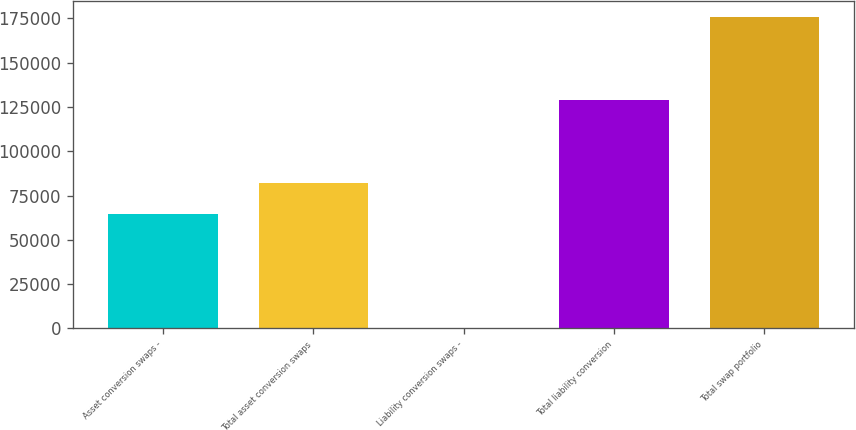Convert chart. <chart><loc_0><loc_0><loc_500><loc_500><bar_chart><fcel>Asset conversion swaps -<fcel>Total asset conversion swaps<fcel>Liability conversion swaps -<fcel>Total liability conversion<fcel>Total swap portfolio<nl><fcel>64408<fcel>81969.3<fcel>319<fcel>128766<fcel>175932<nl></chart> 